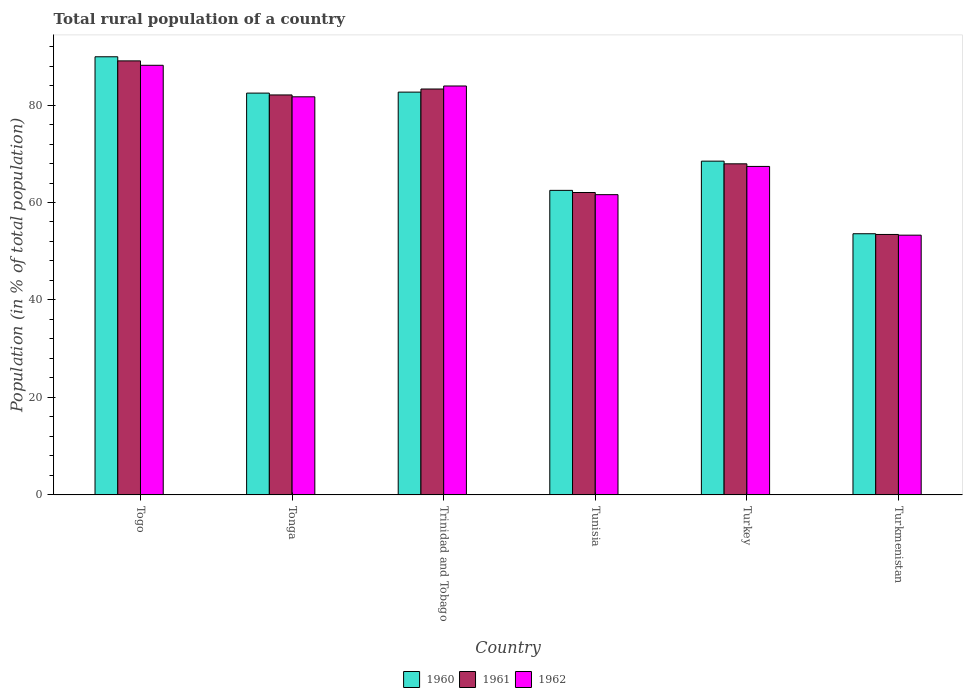How many different coloured bars are there?
Offer a very short reply. 3. Are the number of bars per tick equal to the number of legend labels?
Keep it short and to the point. Yes. Are the number of bars on each tick of the X-axis equal?
Provide a succinct answer. Yes. How many bars are there on the 5th tick from the left?
Keep it short and to the point. 3. How many bars are there on the 3rd tick from the right?
Offer a very short reply. 3. What is the label of the 6th group of bars from the left?
Provide a short and direct response. Turkmenistan. In how many cases, is the number of bars for a given country not equal to the number of legend labels?
Keep it short and to the point. 0. What is the rural population in 1962 in Togo?
Make the answer very short. 88.16. Across all countries, what is the maximum rural population in 1960?
Offer a very short reply. 89.9. Across all countries, what is the minimum rural population in 1962?
Make the answer very short. 53.3. In which country was the rural population in 1961 maximum?
Provide a succinct answer. Togo. In which country was the rural population in 1960 minimum?
Offer a terse response. Turkmenistan. What is the total rural population in 1961 in the graph?
Keep it short and to the point. 437.85. What is the difference between the rural population in 1961 in Tunisia and that in Turkey?
Keep it short and to the point. -5.89. What is the difference between the rural population in 1961 in Togo and the rural population in 1960 in Tonga?
Give a very brief answer. 6.61. What is the average rural population in 1960 per country?
Make the answer very short. 73.26. What is the difference between the rural population of/in 1960 and rural population of/in 1961 in Trinidad and Tobago?
Ensure brevity in your answer.  -0.64. In how many countries, is the rural population in 1962 greater than 76 %?
Offer a terse response. 3. What is the ratio of the rural population in 1962 in Togo to that in Turkmenistan?
Your answer should be very brief. 1.65. Is the difference between the rural population in 1960 in Turkey and Turkmenistan greater than the difference between the rural population in 1961 in Turkey and Turkmenistan?
Your answer should be very brief. Yes. What is the difference between the highest and the second highest rural population in 1960?
Offer a very short reply. 7.25. What is the difference between the highest and the lowest rural population in 1960?
Offer a terse response. 36.31. Is the sum of the rural population in 1962 in Tonga and Trinidad and Tobago greater than the maximum rural population in 1961 across all countries?
Keep it short and to the point. Yes. How many bars are there?
Make the answer very short. 18. How many countries are there in the graph?
Your answer should be very brief. 6. Does the graph contain grids?
Your answer should be compact. No. Where does the legend appear in the graph?
Offer a very short reply. Bottom center. What is the title of the graph?
Offer a terse response. Total rural population of a country. What is the label or title of the Y-axis?
Keep it short and to the point. Population (in % of total population). What is the Population (in % of total population) of 1960 in Togo?
Keep it short and to the point. 89.9. What is the Population (in % of total population) of 1961 in Togo?
Make the answer very short. 89.06. What is the Population (in % of total population) of 1962 in Togo?
Keep it short and to the point. 88.16. What is the Population (in % of total population) in 1960 in Tonga?
Your answer should be compact. 82.45. What is the Population (in % of total population) of 1961 in Tonga?
Your answer should be compact. 82.07. What is the Population (in % of total population) in 1962 in Tonga?
Your answer should be compact. 81.69. What is the Population (in % of total population) of 1960 in Trinidad and Tobago?
Keep it short and to the point. 82.65. What is the Population (in % of total population) of 1961 in Trinidad and Tobago?
Offer a very short reply. 83.29. What is the Population (in % of total population) in 1962 in Trinidad and Tobago?
Make the answer very short. 83.91. What is the Population (in % of total population) in 1960 in Tunisia?
Your response must be concise. 62.49. What is the Population (in % of total population) of 1961 in Tunisia?
Offer a very short reply. 62.05. What is the Population (in % of total population) of 1962 in Tunisia?
Provide a succinct answer. 61.61. What is the Population (in % of total population) of 1960 in Turkey?
Your answer should be compact. 68.48. What is the Population (in % of total population) of 1961 in Turkey?
Offer a terse response. 67.94. What is the Population (in % of total population) in 1962 in Turkey?
Provide a succinct answer. 67.4. What is the Population (in % of total population) of 1960 in Turkmenistan?
Give a very brief answer. 53.59. What is the Population (in % of total population) in 1961 in Turkmenistan?
Make the answer very short. 53.44. What is the Population (in % of total population) in 1962 in Turkmenistan?
Your response must be concise. 53.3. Across all countries, what is the maximum Population (in % of total population) in 1960?
Provide a short and direct response. 89.9. Across all countries, what is the maximum Population (in % of total population) of 1961?
Provide a succinct answer. 89.06. Across all countries, what is the maximum Population (in % of total population) of 1962?
Offer a terse response. 88.16. Across all countries, what is the minimum Population (in % of total population) of 1960?
Provide a short and direct response. 53.59. Across all countries, what is the minimum Population (in % of total population) in 1961?
Offer a very short reply. 53.44. Across all countries, what is the minimum Population (in % of total population) of 1962?
Give a very brief answer. 53.3. What is the total Population (in % of total population) in 1960 in the graph?
Provide a short and direct response. 439.56. What is the total Population (in % of total population) in 1961 in the graph?
Your answer should be very brief. 437.85. What is the total Population (in % of total population) of 1962 in the graph?
Provide a succinct answer. 436.06. What is the difference between the Population (in % of total population) in 1960 in Togo and that in Tonga?
Your answer should be compact. 7.45. What is the difference between the Population (in % of total population) in 1961 in Togo and that in Tonga?
Offer a terse response. 6.99. What is the difference between the Population (in % of total population) in 1962 in Togo and that in Tonga?
Provide a succinct answer. 6.47. What is the difference between the Population (in % of total population) of 1960 in Togo and that in Trinidad and Tobago?
Your response must be concise. 7.25. What is the difference between the Population (in % of total population) of 1961 in Togo and that in Trinidad and Tobago?
Your answer should be compact. 5.77. What is the difference between the Population (in % of total population) in 1962 in Togo and that in Trinidad and Tobago?
Your response must be concise. 4.25. What is the difference between the Population (in % of total population) of 1960 in Togo and that in Tunisia?
Offer a terse response. 27.41. What is the difference between the Population (in % of total population) in 1961 in Togo and that in Tunisia?
Offer a terse response. 27.01. What is the difference between the Population (in % of total population) in 1962 in Togo and that in Tunisia?
Keep it short and to the point. 26.55. What is the difference between the Population (in % of total population) in 1960 in Togo and that in Turkey?
Provide a short and direct response. 21.42. What is the difference between the Population (in % of total population) in 1961 in Togo and that in Turkey?
Your response must be concise. 21.12. What is the difference between the Population (in % of total population) of 1962 in Togo and that in Turkey?
Keep it short and to the point. 20.75. What is the difference between the Population (in % of total population) of 1960 in Togo and that in Turkmenistan?
Your answer should be very brief. 36.31. What is the difference between the Population (in % of total population) of 1961 in Togo and that in Turkmenistan?
Provide a succinct answer. 35.62. What is the difference between the Population (in % of total population) of 1962 in Togo and that in Turkmenistan?
Your answer should be very brief. 34.86. What is the difference between the Population (in % of total population) in 1960 in Tonga and that in Trinidad and Tobago?
Ensure brevity in your answer.  -0.2. What is the difference between the Population (in % of total population) of 1961 in Tonga and that in Trinidad and Tobago?
Your response must be concise. -1.22. What is the difference between the Population (in % of total population) in 1962 in Tonga and that in Trinidad and Tobago?
Offer a terse response. -2.22. What is the difference between the Population (in % of total population) of 1960 in Tonga and that in Tunisia?
Offer a terse response. 19.96. What is the difference between the Population (in % of total population) in 1961 in Tonga and that in Tunisia?
Provide a short and direct response. 20.02. What is the difference between the Population (in % of total population) in 1962 in Tonga and that in Tunisia?
Offer a terse response. 20.08. What is the difference between the Population (in % of total population) of 1960 in Tonga and that in Turkey?
Your answer should be compact. 13.96. What is the difference between the Population (in % of total population) in 1961 in Tonga and that in Turkey?
Keep it short and to the point. 14.13. What is the difference between the Population (in % of total population) of 1962 in Tonga and that in Turkey?
Offer a terse response. 14.29. What is the difference between the Population (in % of total population) in 1960 in Tonga and that in Turkmenistan?
Make the answer very short. 28.86. What is the difference between the Population (in % of total population) in 1961 in Tonga and that in Turkmenistan?
Your response must be concise. 28.63. What is the difference between the Population (in % of total population) of 1962 in Tonga and that in Turkmenistan?
Your response must be concise. 28.39. What is the difference between the Population (in % of total population) in 1960 in Trinidad and Tobago and that in Tunisia?
Your response must be concise. 20.16. What is the difference between the Population (in % of total population) in 1961 in Trinidad and Tobago and that in Tunisia?
Your response must be concise. 21.24. What is the difference between the Population (in % of total population) of 1962 in Trinidad and Tobago and that in Tunisia?
Provide a succinct answer. 22.3. What is the difference between the Population (in % of total population) in 1960 in Trinidad and Tobago and that in Turkey?
Your answer should be very brief. 14.17. What is the difference between the Population (in % of total population) in 1961 in Trinidad and Tobago and that in Turkey?
Keep it short and to the point. 15.35. What is the difference between the Population (in % of total population) in 1962 in Trinidad and Tobago and that in Turkey?
Make the answer very short. 16.5. What is the difference between the Population (in % of total population) of 1960 in Trinidad and Tobago and that in Turkmenistan?
Provide a succinct answer. 29.06. What is the difference between the Population (in % of total population) of 1961 in Trinidad and Tobago and that in Turkmenistan?
Your answer should be compact. 29.84. What is the difference between the Population (in % of total population) of 1962 in Trinidad and Tobago and that in Turkmenistan?
Offer a very short reply. 30.61. What is the difference between the Population (in % of total population) of 1960 in Tunisia and that in Turkey?
Your response must be concise. -6. What is the difference between the Population (in % of total population) of 1961 in Tunisia and that in Turkey?
Make the answer very short. -5.89. What is the difference between the Population (in % of total population) in 1962 in Tunisia and that in Turkey?
Give a very brief answer. -5.79. What is the difference between the Population (in % of total population) in 1960 in Tunisia and that in Turkmenistan?
Give a very brief answer. 8.9. What is the difference between the Population (in % of total population) in 1961 in Tunisia and that in Turkmenistan?
Keep it short and to the point. 8.61. What is the difference between the Population (in % of total population) in 1962 in Tunisia and that in Turkmenistan?
Make the answer very short. 8.31. What is the difference between the Population (in % of total population) of 1960 in Turkey and that in Turkmenistan?
Keep it short and to the point. 14.9. What is the difference between the Population (in % of total population) of 1961 in Turkey and that in Turkmenistan?
Keep it short and to the point. 14.49. What is the difference between the Population (in % of total population) of 1962 in Turkey and that in Turkmenistan?
Ensure brevity in your answer.  14.1. What is the difference between the Population (in % of total population) in 1960 in Togo and the Population (in % of total population) in 1961 in Tonga?
Offer a terse response. 7.83. What is the difference between the Population (in % of total population) of 1960 in Togo and the Population (in % of total population) of 1962 in Tonga?
Make the answer very short. 8.21. What is the difference between the Population (in % of total population) of 1961 in Togo and the Population (in % of total population) of 1962 in Tonga?
Offer a very short reply. 7.37. What is the difference between the Population (in % of total population) of 1960 in Togo and the Population (in % of total population) of 1961 in Trinidad and Tobago?
Your answer should be very brief. 6.61. What is the difference between the Population (in % of total population) of 1960 in Togo and the Population (in % of total population) of 1962 in Trinidad and Tobago?
Offer a terse response. 6. What is the difference between the Population (in % of total population) of 1961 in Togo and the Population (in % of total population) of 1962 in Trinidad and Tobago?
Your answer should be very brief. 5.15. What is the difference between the Population (in % of total population) of 1960 in Togo and the Population (in % of total population) of 1961 in Tunisia?
Provide a succinct answer. 27.85. What is the difference between the Population (in % of total population) of 1960 in Togo and the Population (in % of total population) of 1962 in Tunisia?
Ensure brevity in your answer.  28.29. What is the difference between the Population (in % of total population) in 1961 in Togo and the Population (in % of total population) in 1962 in Tunisia?
Give a very brief answer. 27.45. What is the difference between the Population (in % of total population) of 1960 in Togo and the Population (in % of total population) of 1961 in Turkey?
Ensure brevity in your answer.  21.97. What is the difference between the Population (in % of total population) in 1960 in Togo and the Population (in % of total population) in 1962 in Turkey?
Offer a terse response. 22.5. What is the difference between the Population (in % of total population) in 1961 in Togo and the Population (in % of total population) in 1962 in Turkey?
Your response must be concise. 21.66. What is the difference between the Population (in % of total population) in 1960 in Togo and the Population (in % of total population) in 1961 in Turkmenistan?
Your response must be concise. 36.46. What is the difference between the Population (in % of total population) of 1960 in Togo and the Population (in % of total population) of 1962 in Turkmenistan?
Your response must be concise. 36.6. What is the difference between the Population (in % of total population) in 1961 in Togo and the Population (in % of total population) in 1962 in Turkmenistan?
Offer a very short reply. 35.76. What is the difference between the Population (in % of total population) in 1960 in Tonga and the Population (in % of total population) in 1961 in Trinidad and Tobago?
Provide a succinct answer. -0.84. What is the difference between the Population (in % of total population) in 1960 in Tonga and the Population (in % of total population) in 1962 in Trinidad and Tobago?
Offer a very short reply. -1.46. What is the difference between the Population (in % of total population) in 1961 in Tonga and the Population (in % of total population) in 1962 in Trinidad and Tobago?
Your answer should be very brief. -1.84. What is the difference between the Population (in % of total population) in 1960 in Tonga and the Population (in % of total population) in 1961 in Tunisia?
Provide a succinct answer. 20.4. What is the difference between the Population (in % of total population) in 1960 in Tonga and the Population (in % of total population) in 1962 in Tunisia?
Your answer should be compact. 20.84. What is the difference between the Population (in % of total population) of 1961 in Tonga and the Population (in % of total population) of 1962 in Tunisia?
Keep it short and to the point. 20.46. What is the difference between the Population (in % of total population) of 1960 in Tonga and the Population (in % of total population) of 1961 in Turkey?
Ensure brevity in your answer.  14.51. What is the difference between the Population (in % of total population) of 1960 in Tonga and the Population (in % of total population) of 1962 in Turkey?
Make the answer very short. 15.05. What is the difference between the Population (in % of total population) in 1961 in Tonga and the Population (in % of total population) in 1962 in Turkey?
Your answer should be very brief. 14.67. What is the difference between the Population (in % of total population) in 1960 in Tonga and the Population (in % of total population) in 1961 in Turkmenistan?
Your answer should be compact. 29. What is the difference between the Population (in % of total population) in 1960 in Tonga and the Population (in % of total population) in 1962 in Turkmenistan?
Ensure brevity in your answer.  29.15. What is the difference between the Population (in % of total population) of 1961 in Tonga and the Population (in % of total population) of 1962 in Turkmenistan?
Your response must be concise. 28.77. What is the difference between the Population (in % of total population) of 1960 in Trinidad and Tobago and the Population (in % of total population) of 1961 in Tunisia?
Offer a very short reply. 20.6. What is the difference between the Population (in % of total population) of 1960 in Trinidad and Tobago and the Population (in % of total population) of 1962 in Tunisia?
Offer a terse response. 21.04. What is the difference between the Population (in % of total population) in 1961 in Trinidad and Tobago and the Population (in % of total population) in 1962 in Tunisia?
Give a very brief answer. 21.68. What is the difference between the Population (in % of total population) in 1960 in Trinidad and Tobago and the Population (in % of total population) in 1961 in Turkey?
Ensure brevity in your answer.  14.71. What is the difference between the Population (in % of total population) in 1960 in Trinidad and Tobago and the Population (in % of total population) in 1962 in Turkey?
Offer a terse response. 15.25. What is the difference between the Population (in % of total population) in 1961 in Trinidad and Tobago and the Population (in % of total population) in 1962 in Turkey?
Keep it short and to the point. 15.89. What is the difference between the Population (in % of total population) of 1960 in Trinidad and Tobago and the Population (in % of total population) of 1961 in Turkmenistan?
Give a very brief answer. 29.21. What is the difference between the Population (in % of total population) in 1960 in Trinidad and Tobago and the Population (in % of total population) in 1962 in Turkmenistan?
Ensure brevity in your answer.  29.35. What is the difference between the Population (in % of total population) of 1961 in Trinidad and Tobago and the Population (in % of total population) of 1962 in Turkmenistan?
Offer a terse response. 29.99. What is the difference between the Population (in % of total population) in 1960 in Tunisia and the Population (in % of total population) in 1961 in Turkey?
Your answer should be very brief. -5.45. What is the difference between the Population (in % of total population) of 1960 in Tunisia and the Population (in % of total population) of 1962 in Turkey?
Offer a very short reply. -4.91. What is the difference between the Population (in % of total population) of 1961 in Tunisia and the Population (in % of total population) of 1962 in Turkey?
Ensure brevity in your answer.  -5.35. What is the difference between the Population (in % of total population) in 1960 in Tunisia and the Population (in % of total population) in 1961 in Turkmenistan?
Your answer should be compact. 9.05. What is the difference between the Population (in % of total population) in 1960 in Tunisia and the Population (in % of total population) in 1962 in Turkmenistan?
Ensure brevity in your answer.  9.19. What is the difference between the Population (in % of total population) of 1961 in Tunisia and the Population (in % of total population) of 1962 in Turkmenistan?
Your response must be concise. 8.75. What is the difference between the Population (in % of total population) of 1960 in Turkey and the Population (in % of total population) of 1961 in Turkmenistan?
Ensure brevity in your answer.  15.04. What is the difference between the Population (in % of total population) of 1960 in Turkey and the Population (in % of total population) of 1962 in Turkmenistan?
Ensure brevity in your answer.  15.19. What is the difference between the Population (in % of total population) of 1961 in Turkey and the Population (in % of total population) of 1962 in Turkmenistan?
Ensure brevity in your answer.  14.64. What is the average Population (in % of total population) of 1960 per country?
Offer a terse response. 73.26. What is the average Population (in % of total population) in 1961 per country?
Make the answer very short. 72.97. What is the average Population (in % of total population) of 1962 per country?
Provide a short and direct response. 72.68. What is the difference between the Population (in % of total population) in 1960 and Population (in % of total population) in 1961 in Togo?
Your answer should be very brief. 0.84. What is the difference between the Population (in % of total population) in 1960 and Population (in % of total population) in 1962 in Togo?
Provide a succinct answer. 1.75. What is the difference between the Population (in % of total population) in 1961 and Population (in % of total population) in 1962 in Togo?
Your answer should be very brief. 0.9. What is the difference between the Population (in % of total population) in 1960 and Population (in % of total population) in 1961 in Tonga?
Your response must be concise. 0.38. What is the difference between the Population (in % of total population) in 1960 and Population (in % of total population) in 1962 in Tonga?
Make the answer very short. 0.76. What is the difference between the Population (in % of total population) of 1961 and Population (in % of total population) of 1962 in Tonga?
Provide a succinct answer. 0.38. What is the difference between the Population (in % of total population) in 1960 and Population (in % of total population) in 1961 in Trinidad and Tobago?
Offer a terse response. -0.64. What is the difference between the Population (in % of total population) of 1960 and Population (in % of total population) of 1962 in Trinidad and Tobago?
Provide a succinct answer. -1.26. What is the difference between the Population (in % of total population) of 1961 and Population (in % of total population) of 1962 in Trinidad and Tobago?
Provide a short and direct response. -0.62. What is the difference between the Population (in % of total population) in 1960 and Population (in % of total population) in 1961 in Tunisia?
Make the answer very short. 0.44. What is the difference between the Population (in % of total population) in 1960 and Population (in % of total population) in 1962 in Tunisia?
Your answer should be very brief. 0.88. What is the difference between the Population (in % of total population) of 1961 and Population (in % of total population) of 1962 in Tunisia?
Your answer should be compact. 0.44. What is the difference between the Population (in % of total population) of 1960 and Population (in % of total population) of 1961 in Turkey?
Your answer should be very brief. 0.55. What is the difference between the Population (in % of total population) of 1960 and Population (in % of total population) of 1962 in Turkey?
Make the answer very short. 1.08. What is the difference between the Population (in % of total population) of 1961 and Population (in % of total population) of 1962 in Turkey?
Ensure brevity in your answer.  0.53. What is the difference between the Population (in % of total population) in 1960 and Population (in % of total population) in 1961 in Turkmenistan?
Give a very brief answer. 0.14. What is the difference between the Population (in % of total population) in 1960 and Population (in % of total population) in 1962 in Turkmenistan?
Your answer should be very brief. 0.29. What is the difference between the Population (in % of total population) in 1961 and Population (in % of total population) in 1962 in Turkmenistan?
Offer a terse response. 0.14. What is the ratio of the Population (in % of total population) of 1960 in Togo to that in Tonga?
Your answer should be very brief. 1.09. What is the ratio of the Population (in % of total population) in 1961 in Togo to that in Tonga?
Make the answer very short. 1.09. What is the ratio of the Population (in % of total population) in 1962 in Togo to that in Tonga?
Your answer should be compact. 1.08. What is the ratio of the Population (in % of total population) of 1960 in Togo to that in Trinidad and Tobago?
Provide a short and direct response. 1.09. What is the ratio of the Population (in % of total population) in 1961 in Togo to that in Trinidad and Tobago?
Provide a succinct answer. 1.07. What is the ratio of the Population (in % of total population) of 1962 in Togo to that in Trinidad and Tobago?
Offer a very short reply. 1.05. What is the ratio of the Population (in % of total population) of 1960 in Togo to that in Tunisia?
Your answer should be very brief. 1.44. What is the ratio of the Population (in % of total population) of 1961 in Togo to that in Tunisia?
Offer a terse response. 1.44. What is the ratio of the Population (in % of total population) of 1962 in Togo to that in Tunisia?
Make the answer very short. 1.43. What is the ratio of the Population (in % of total population) of 1960 in Togo to that in Turkey?
Your answer should be compact. 1.31. What is the ratio of the Population (in % of total population) of 1961 in Togo to that in Turkey?
Provide a short and direct response. 1.31. What is the ratio of the Population (in % of total population) of 1962 in Togo to that in Turkey?
Provide a succinct answer. 1.31. What is the ratio of the Population (in % of total population) in 1960 in Togo to that in Turkmenistan?
Your answer should be compact. 1.68. What is the ratio of the Population (in % of total population) of 1961 in Togo to that in Turkmenistan?
Give a very brief answer. 1.67. What is the ratio of the Population (in % of total population) in 1962 in Togo to that in Turkmenistan?
Your answer should be very brief. 1.65. What is the ratio of the Population (in % of total population) in 1961 in Tonga to that in Trinidad and Tobago?
Offer a terse response. 0.99. What is the ratio of the Population (in % of total population) of 1962 in Tonga to that in Trinidad and Tobago?
Provide a succinct answer. 0.97. What is the ratio of the Population (in % of total population) of 1960 in Tonga to that in Tunisia?
Your answer should be very brief. 1.32. What is the ratio of the Population (in % of total population) of 1961 in Tonga to that in Tunisia?
Make the answer very short. 1.32. What is the ratio of the Population (in % of total population) in 1962 in Tonga to that in Tunisia?
Give a very brief answer. 1.33. What is the ratio of the Population (in % of total population) of 1960 in Tonga to that in Turkey?
Make the answer very short. 1.2. What is the ratio of the Population (in % of total population) in 1961 in Tonga to that in Turkey?
Your answer should be very brief. 1.21. What is the ratio of the Population (in % of total population) in 1962 in Tonga to that in Turkey?
Keep it short and to the point. 1.21. What is the ratio of the Population (in % of total population) in 1960 in Tonga to that in Turkmenistan?
Your answer should be very brief. 1.54. What is the ratio of the Population (in % of total population) of 1961 in Tonga to that in Turkmenistan?
Give a very brief answer. 1.54. What is the ratio of the Population (in % of total population) in 1962 in Tonga to that in Turkmenistan?
Offer a very short reply. 1.53. What is the ratio of the Population (in % of total population) in 1960 in Trinidad and Tobago to that in Tunisia?
Your answer should be compact. 1.32. What is the ratio of the Population (in % of total population) in 1961 in Trinidad and Tobago to that in Tunisia?
Offer a very short reply. 1.34. What is the ratio of the Population (in % of total population) in 1962 in Trinidad and Tobago to that in Tunisia?
Provide a succinct answer. 1.36. What is the ratio of the Population (in % of total population) of 1960 in Trinidad and Tobago to that in Turkey?
Give a very brief answer. 1.21. What is the ratio of the Population (in % of total population) of 1961 in Trinidad and Tobago to that in Turkey?
Your response must be concise. 1.23. What is the ratio of the Population (in % of total population) in 1962 in Trinidad and Tobago to that in Turkey?
Provide a succinct answer. 1.24. What is the ratio of the Population (in % of total population) of 1960 in Trinidad and Tobago to that in Turkmenistan?
Ensure brevity in your answer.  1.54. What is the ratio of the Population (in % of total population) of 1961 in Trinidad and Tobago to that in Turkmenistan?
Your answer should be compact. 1.56. What is the ratio of the Population (in % of total population) of 1962 in Trinidad and Tobago to that in Turkmenistan?
Your response must be concise. 1.57. What is the ratio of the Population (in % of total population) of 1960 in Tunisia to that in Turkey?
Keep it short and to the point. 0.91. What is the ratio of the Population (in % of total population) of 1961 in Tunisia to that in Turkey?
Make the answer very short. 0.91. What is the ratio of the Population (in % of total population) of 1962 in Tunisia to that in Turkey?
Offer a very short reply. 0.91. What is the ratio of the Population (in % of total population) of 1960 in Tunisia to that in Turkmenistan?
Your answer should be compact. 1.17. What is the ratio of the Population (in % of total population) of 1961 in Tunisia to that in Turkmenistan?
Your answer should be very brief. 1.16. What is the ratio of the Population (in % of total population) in 1962 in Tunisia to that in Turkmenistan?
Your answer should be very brief. 1.16. What is the ratio of the Population (in % of total population) in 1960 in Turkey to that in Turkmenistan?
Provide a short and direct response. 1.28. What is the ratio of the Population (in % of total population) in 1961 in Turkey to that in Turkmenistan?
Provide a short and direct response. 1.27. What is the ratio of the Population (in % of total population) in 1962 in Turkey to that in Turkmenistan?
Keep it short and to the point. 1.26. What is the difference between the highest and the second highest Population (in % of total population) in 1960?
Your answer should be compact. 7.25. What is the difference between the highest and the second highest Population (in % of total population) of 1961?
Keep it short and to the point. 5.77. What is the difference between the highest and the second highest Population (in % of total population) of 1962?
Make the answer very short. 4.25. What is the difference between the highest and the lowest Population (in % of total population) of 1960?
Your answer should be compact. 36.31. What is the difference between the highest and the lowest Population (in % of total population) of 1961?
Your answer should be compact. 35.62. What is the difference between the highest and the lowest Population (in % of total population) in 1962?
Your answer should be compact. 34.86. 